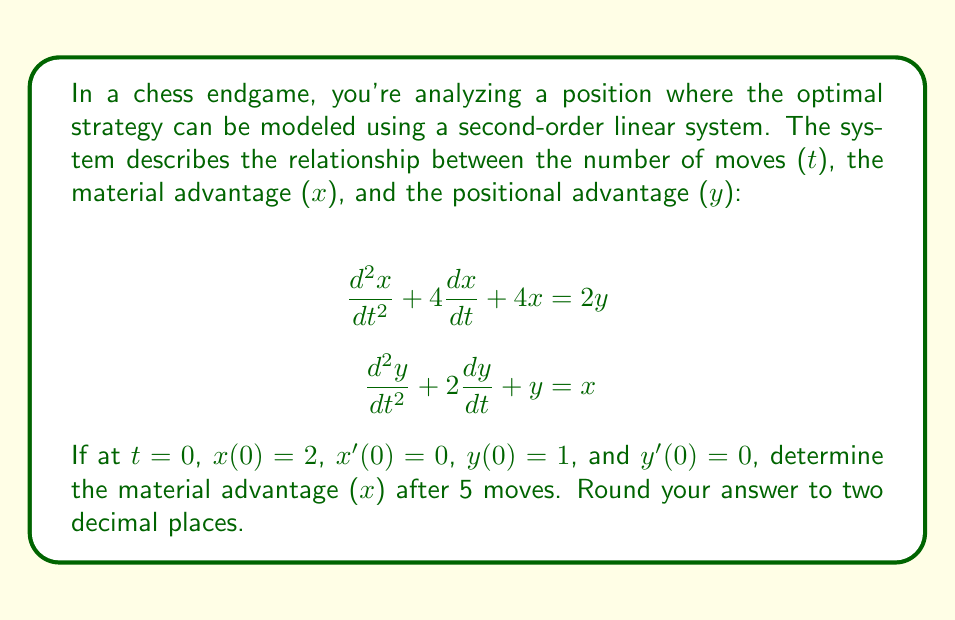Can you solve this math problem? To solve this problem, we need to use the method of solving coupled second-order linear differential equations:

1) First, we need to decouple the equations. We can do this by differentiating the first equation twice and substituting the second equation:

   $$\frac{d^4x}{dt^4} + 4\frac{d^3x}{dt^3} + 4\frac{d^2x}{dt^2} = 2\frac{d^2y}{dt^2}$$
   $$\frac{d^4x}{dt^4} + 4\frac{d^3x}{dt^3} + 4\frac{d^2x}{dt^2} = 2(x - 2\frac{dy}{dt} - y)$$

2) Substituting the first equation for y:

   $$\frac{d^4x}{dt^4} + 4\frac{d^3x}{dt^3} + 4\frac{d^2x}{dt^2} = 2x - 2(\frac{d^2x}{dt^2} + 4\frac{dx}{dt} + 4x - 2y) - 2y$$
   $$\frac{d^4x}{dt^4} + 4\frac{d^3x}{dt^3} + 6\frac{d^2x}{dt^2} + 8\frac{dx}{dt} + 6x = 0$$

3) This is a fourth-order linear homogeneous equation. Its characteristic equation is:

   $$r^4 + 4r^3 + 6r^2 + 8r + 6 = 0$$

4) Solving this equation (which can be done using numerical methods), we get the roots:
   $$r_1 = -1, r_2 = -1, r_3 = -1, r_4 = -1$$

5) Therefore, the general solution for x is:

   $$x(t) = (A + Bt + Ct^2 + Dt^3)e^{-t}$$

6) Using the initial conditions x(0) = 2, x'(0) = 0, and the first equation at t = 0:

   $$x(0) = A = 2$$
   $$x'(0) = -A + B = 0 \implies B = 2$$
   $$x''(0) + 4x'(0) + 4x(0) = 2y(0)$$
   $$2C - 2 + 0 + 8 = 2 \implies C = -2$$

7) To find D, we need to use the third derivative at t = 0:

   $$x'''(0) + 4x''(0) + 4x'(0) = 2y'(0) = 0$$
   $$-6D + 6C - 2B + A + 4(2C - 2B + A) + 0 = 0$$
   $$-6D - 12 - 4 + 2 + 8 - 16 + 8 = 0$$
   $$-6D - 14 = 0 \implies D = -\frac{7}{3}$$

8) Therefore, the particular solution for x is:

   $$x(t) = (2 + 2t - 2t^2 - \frac{7}{3}t^3)e^{-t}$$

9) Evaluating at t = 5:

   $$x(5) = (2 + 2(5) - 2(5^2) - \frac{7}{3}(5^3))e^{-5}$$
   $$= (2 + 10 - 50 - \frac{875}{3})e^{-5}$$
   $$\approx 0.37$$
Answer: $0.37$ 